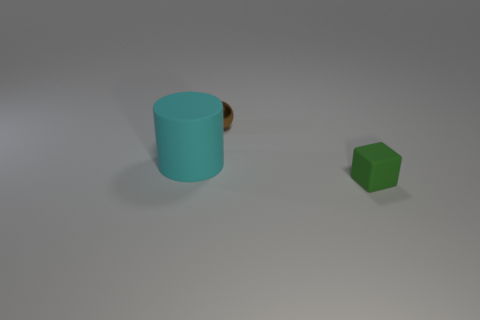Add 3 yellow rubber cylinders. How many objects exist? 6 Subtract all cubes. How many objects are left? 2 Subtract all small blue metallic cylinders. Subtract all tiny green rubber things. How many objects are left? 2 Add 1 big matte cylinders. How many big matte cylinders are left? 2 Add 2 tiny purple matte balls. How many tiny purple matte balls exist? 2 Subtract 0 gray blocks. How many objects are left? 3 